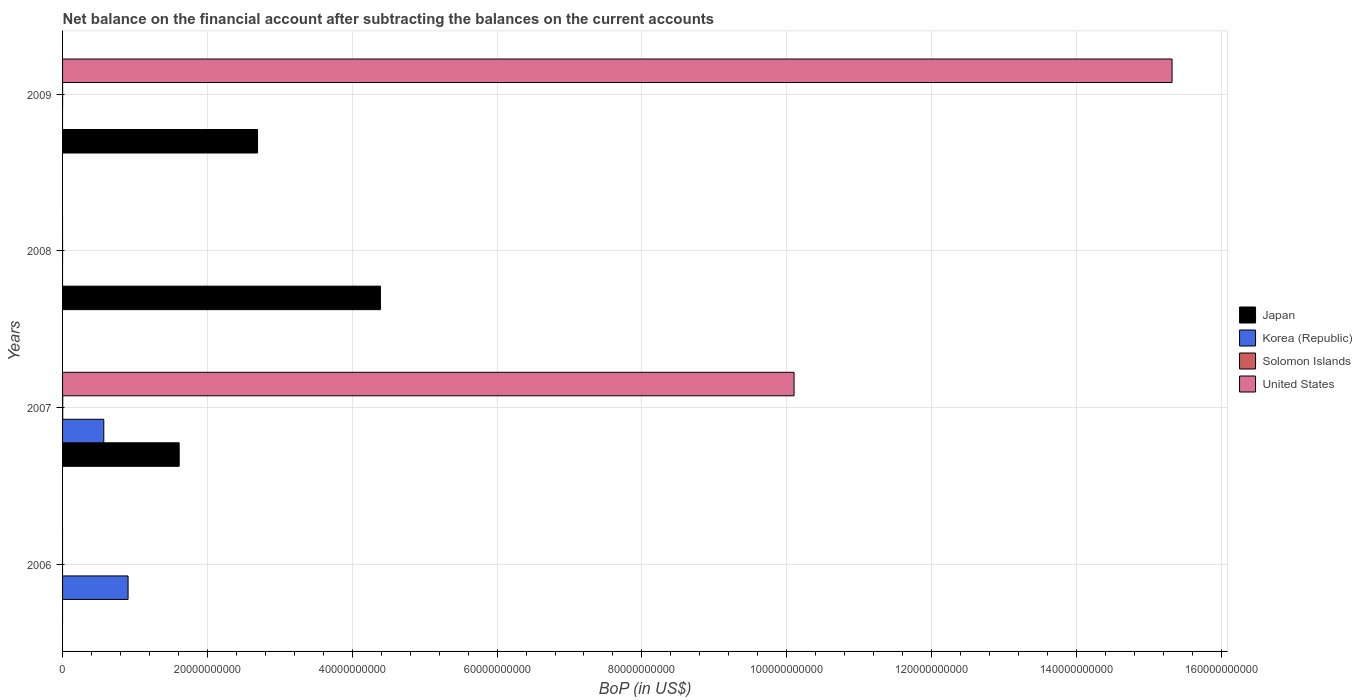How many different coloured bars are there?
Make the answer very short. 4. Are the number of bars per tick equal to the number of legend labels?
Your answer should be compact. No. In how many cases, is the number of bars for a given year not equal to the number of legend labels?
Provide a short and direct response. 3. What is the Balance of Payments in Japan in 2008?
Your answer should be compact. 4.39e+1. Across all years, what is the maximum Balance of Payments in Korea (Republic)?
Offer a very short reply. 9.05e+09. Across all years, what is the minimum Balance of Payments in Japan?
Make the answer very short. 0. What is the total Balance of Payments in United States in the graph?
Provide a short and direct response. 2.54e+11. What is the difference between the Balance of Payments in Japan in 2008 and that in 2009?
Make the answer very short. 1.70e+1. What is the difference between the Balance of Payments in United States in 2009 and the Balance of Payments in Korea (Republic) in 2008?
Your response must be concise. 1.53e+11. What is the average Balance of Payments in Korea (Republic) per year?
Offer a very short reply. 3.68e+09. In the year 2007, what is the difference between the Balance of Payments in United States and Balance of Payments in Solomon Islands?
Your answer should be compact. 1.01e+11. What is the ratio of the Balance of Payments in United States in 2007 to that in 2009?
Provide a short and direct response. 0.66. What is the difference between the highest and the second highest Balance of Payments in Japan?
Provide a short and direct response. 1.70e+1. What is the difference between the highest and the lowest Balance of Payments in Japan?
Provide a short and direct response. 4.39e+1. Is it the case that in every year, the sum of the Balance of Payments in Korea (Republic) and Balance of Payments in Solomon Islands is greater than the Balance of Payments in Japan?
Offer a terse response. No. How many bars are there?
Your response must be concise. 9. What is the difference between two consecutive major ticks on the X-axis?
Make the answer very short. 2.00e+1. Are the values on the major ticks of X-axis written in scientific E-notation?
Provide a short and direct response. No. Does the graph contain any zero values?
Offer a very short reply. Yes. Does the graph contain grids?
Provide a short and direct response. Yes. How many legend labels are there?
Your response must be concise. 4. How are the legend labels stacked?
Ensure brevity in your answer.  Vertical. What is the title of the graph?
Provide a short and direct response. Net balance on the financial account after subtracting the balances on the current accounts. What is the label or title of the X-axis?
Provide a short and direct response. BoP (in US$). What is the label or title of the Y-axis?
Give a very brief answer. Years. What is the BoP (in US$) of Japan in 2006?
Your answer should be very brief. 0. What is the BoP (in US$) of Korea (Republic) in 2006?
Your answer should be compact. 9.05e+09. What is the BoP (in US$) of Solomon Islands in 2006?
Your answer should be compact. 0. What is the BoP (in US$) of Japan in 2007?
Your answer should be compact. 1.61e+1. What is the BoP (in US$) in Korea (Republic) in 2007?
Provide a succinct answer. 5.69e+09. What is the BoP (in US$) of Solomon Islands in 2007?
Give a very brief answer. 1.83e+07. What is the BoP (in US$) of United States in 2007?
Provide a short and direct response. 1.01e+11. What is the BoP (in US$) of Japan in 2008?
Provide a short and direct response. 4.39e+1. What is the BoP (in US$) in Japan in 2009?
Provide a short and direct response. 2.69e+1. What is the BoP (in US$) in Korea (Republic) in 2009?
Ensure brevity in your answer.  0. What is the BoP (in US$) of Solomon Islands in 2009?
Give a very brief answer. 4.36e+06. What is the BoP (in US$) of United States in 2009?
Your answer should be compact. 1.53e+11. Across all years, what is the maximum BoP (in US$) of Japan?
Your response must be concise. 4.39e+1. Across all years, what is the maximum BoP (in US$) in Korea (Republic)?
Make the answer very short. 9.05e+09. Across all years, what is the maximum BoP (in US$) of Solomon Islands?
Your answer should be compact. 1.83e+07. Across all years, what is the maximum BoP (in US$) in United States?
Ensure brevity in your answer.  1.53e+11. Across all years, what is the minimum BoP (in US$) of United States?
Offer a very short reply. 0. What is the total BoP (in US$) in Japan in the graph?
Offer a terse response. 8.69e+1. What is the total BoP (in US$) in Korea (Republic) in the graph?
Offer a very short reply. 1.47e+1. What is the total BoP (in US$) in Solomon Islands in the graph?
Make the answer very short. 2.26e+07. What is the total BoP (in US$) of United States in the graph?
Your answer should be very brief. 2.54e+11. What is the difference between the BoP (in US$) of Korea (Republic) in 2006 and that in 2007?
Keep it short and to the point. 3.35e+09. What is the difference between the BoP (in US$) of Japan in 2007 and that in 2008?
Your response must be concise. -2.78e+1. What is the difference between the BoP (in US$) in Japan in 2007 and that in 2009?
Provide a short and direct response. -1.08e+1. What is the difference between the BoP (in US$) of Solomon Islands in 2007 and that in 2009?
Your answer should be very brief. 1.39e+07. What is the difference between the BoP (in US$) in United States in 2007 and that in 2009?
Your answer should be compact. -5.22e+1. What is the difference between the BoP (in US$) of Japan in 2008 and that in 2009?
Keep it short and to the point. 1.70e+1. What is the difference between the BoP (in US$) of Korea (Republic) in 2006 and the BoP (in US$) of Solomon Islands in 2007?
Offer a very short reply. 9.03e+09. What is the difference between the BoP (in US$) of Korea (Republic) in 2006 and the BoP (in US$) of United States in 2007?
Give a very brief answer. -9.20e+1. What is the difference between the BoP (in US$) of Korea (Republic) in 2006 and the BoP (in US$) of Solomon Islands in 2009?
Give a very brief answer. 9.04e+09. What is the difference between the BoP (in US$) in Korea (Republic) in 2006 and the BoP (in US$) in United States in 2009?
Provide a succinct answer. -1.44e+11. What is the difference between the BoP (in US$) in Japan in 2007 and the BoP (in US$) in Solomon Islands in 2009?
Your answer should be compact. 1.61e+1. What is the difference between the BoP (in US$) of Japan in 2007 and the BoP (in US$) of United States in 2009?
Your response must be concise. -1.37e+11. What is the difference between the BoP (in US$) in Korea (Republic) in 2007 and the BoP (in US$) in Solomon Islands in 2009?
Keep it short and to the point. 5.69e+09. What is the difference between the BoP (in US$) in Korea (Republic) in 2007 and the BoP (in US$) in United States in 2009?
Give a very brief answer. -1.48e+11. What is the difference between the BoP (in US$) in Solomon Islands in 2007 and the BoP (in US$) in United States in 2009?
Your answer should be very brief. -1.53e+11. What is the difference between the BoP (in US$) of Japan in 2008 and the BoP (in US$) of Solomon Islands in 2009?
Ensure brevity in your answer.  4.39e+1. What is the difference between the BoP (in US$) in Japan in 2008 and the BoP (in US$) in United States in 2009?
Keep it short and to the point. -1.09e+11. What is the average BoP (in US$) of Japan per year?
Offer a very short reply. 2.17e+1. What is the average BoP (in US$) in Korea (Republic) per year?
Your answer should be compact. 3.68e+09. What is the average BoP (in US$) in Solomon Islands per year?
Provide a succinct answer. 5.65e+06. What is the average BoP (in US$) of United States per year?
Your answer should be very brief. 6.36e+1. In the year 2007, what is the difference between the BoP (in US$) of Japan and BoP (in US$) of Korea (Republic)?
Your answer should be very brief. 1.04e+1. In the year 2007, what is the difference between the BoP (in US$) of Japan and BoP (in US$) of Solomon Islands?
Your response must be concise. 1.61e+1. In the year 2007, what is the difference between the BoP (in US$) in Japan and BoP (in US$) in United States?
Offer a terse response. -8.49e+1. In the year 2007, what is the difference between the BoP (in US$) of Korea (Republic) and BoP (in US$) of Solomon Islands?
Offer a very short reply. 5.68e+09. In the year 2007, what is the difference between the BoP (in US$) in Korea (Republic) and BoP (in US$) in United States?
Your answer should be very brief. -9.53e+1. In the year 2007, what is the difference between the BoP (in US$) of Solomon Islands and BoP (in US$) of United States?
Your answer should be compact. -1.01e+11. In the year 2009, what is the difference between the BoP (in US$) in Japan and BoP (in US$) in Solomon Islands?
Make the answer very short. 2.69e+1. In the year 2009, what is the difference between the BoP (in US$) in Japan and BoP (in US$) in United States?
Your response must be concise. -1.26e+11. In the year 2009, what is the difference between the BoP (in US$) in Solomon Islands and BoP (in US$) in United States?
Ensure brevity in your answer.  -1.53e+11. What is the ratio of the BoP (in US$) of Korea (Republic) in 2006 to that in 2007?
Keep it short and to the point. 1.59. What is the ratio of the BoP (in US$) of Japan in 2007 to that in 2008?
Your response must be concise. 0.37. What is the ratio of the BoP (in US$) in Japan in 2007 to that in 2009?
Offer a very short reply. 0.6. What is the ratio of the BoP (in US$) of Solomon Islands in 2007 to that in 2009?
Give a very brief answer. 4.19. What is the ratio of the BoP (in US$) of United States in 2007 to that in 2009?
Your answer should be very brief. 0.66. What is the ratio of the BoP (in US$) in Japan in 2008 to that in 2009?
Your answer should be compact. 1.63. What is the difference between the highest and the second highest BoP (in US$) in Japan?
Ensure brevity in your answer.  1.70e+1. What is the difference between the highest and the lowest BoP (in US$) of Japan?
Make the answer very short. 4.39e+1. What is the difference between the highest and the lowest BoP (in US$) of Korea (Republic)?
Your answer should be compact. 9.05e+09. What is the difference between the highest and the lowest BoP (in US$) of Solomon Islands?
Provide a short and direct response. 1.83e+07. What is the difference between the highest and the lowest BoP (in US$) of United States?
Ensure brevity in your answer.  1.53e+11. 